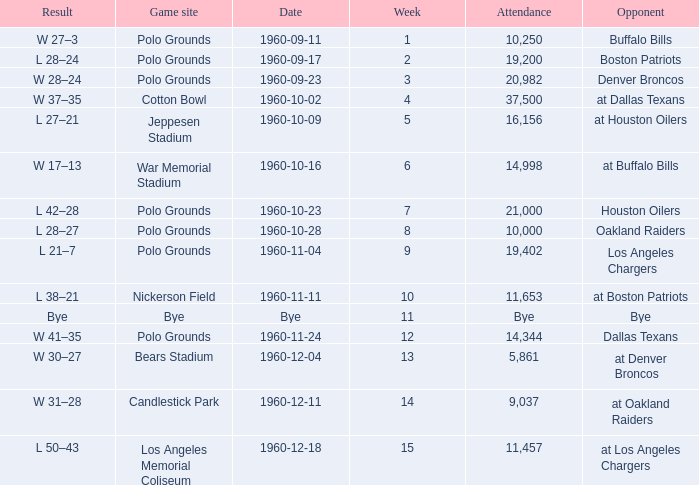What day did they play at candlestick park? 1960-12-11. 